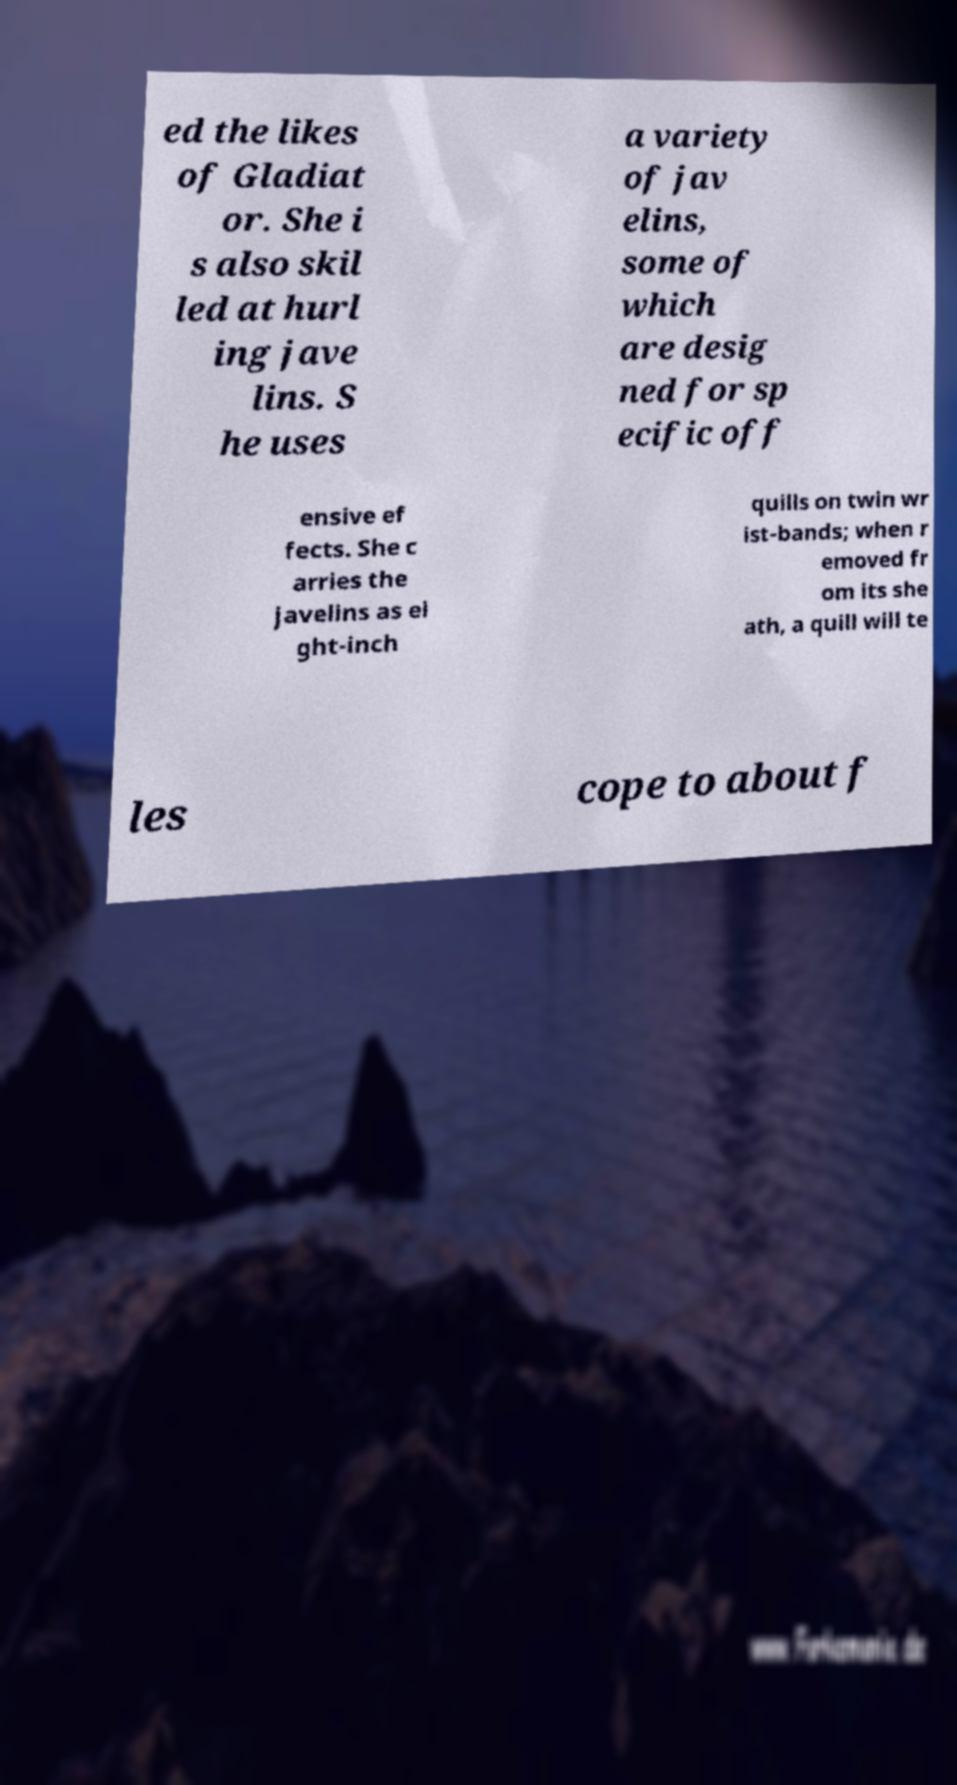Please identify and transcribe the text found in this image. ed the likes of Gladiat or. She i s also skil led at hurl ing jave lins. S he uses a variety of jav elins, some of which are desig ned for sp ecific off ensive ef fects. She c arries the javelins as ei ght-inch quills on twin wr ist-bands; when r emoved fr om its she ath, a quill will te les cope to about f 